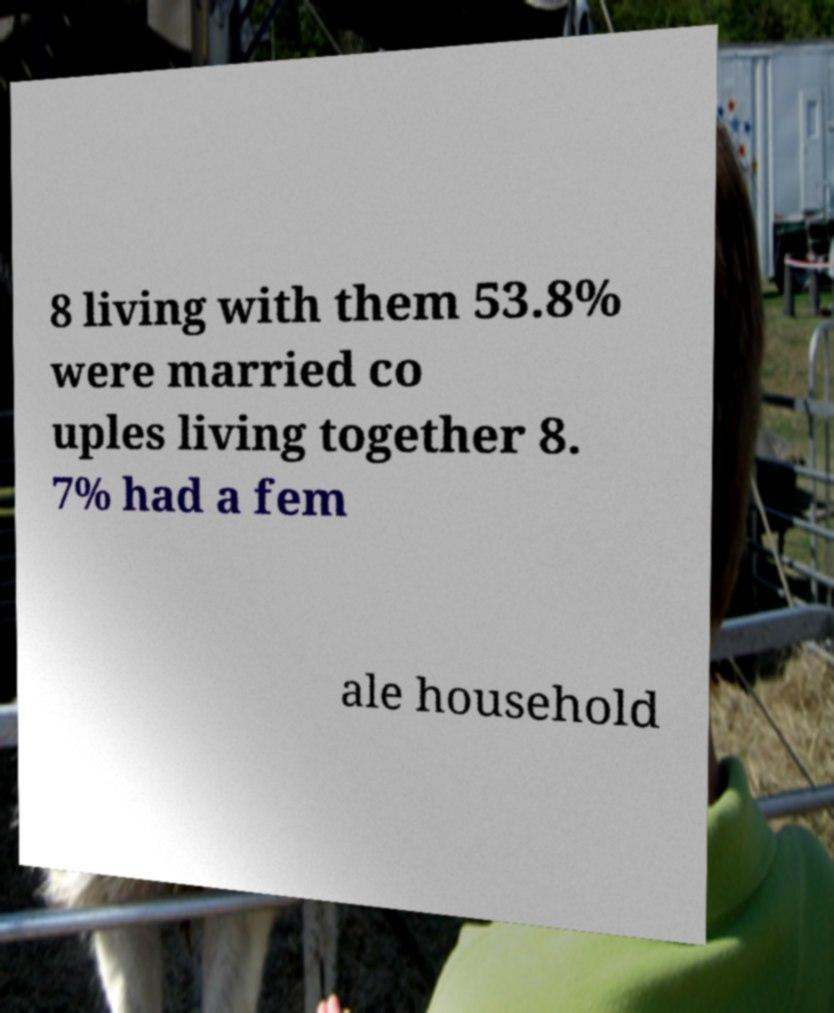Can you read and provide the text displayed in the image?This photo seems to have some interesting text. Can you extract and type it out for me? 8 living with them 53.8% were married co uples living together 8. 7% had a fem ale household 